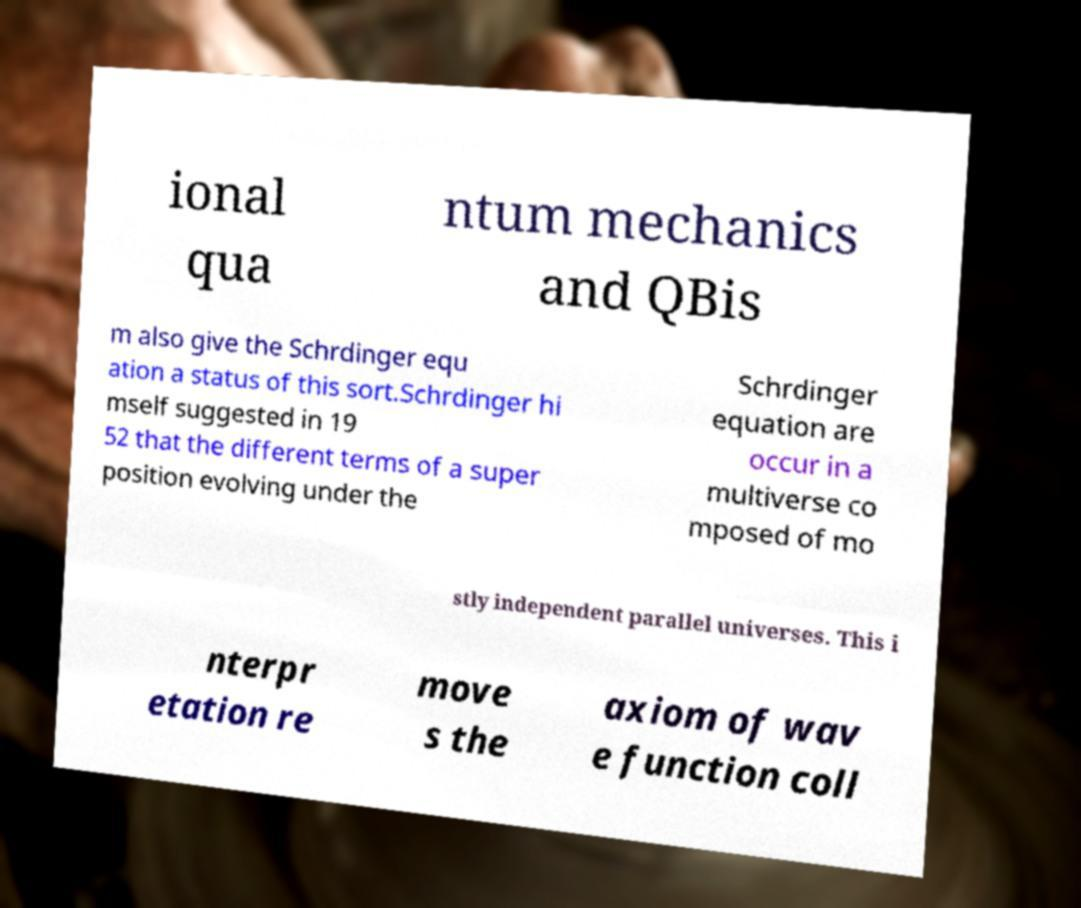Could you extract and type out the text from this image? ional qua ntum mechanics and QBis m also give the Schrdinger equ ation a status of this sort.Schrdinger hi mself suggested in 19 52 that the different terms of a super position evolving under the Schrdinger equation are occur in a multiverse co mposed of mo stly independent parallel universes. This i nterpr etation re move s the axiom of wav e function coll 